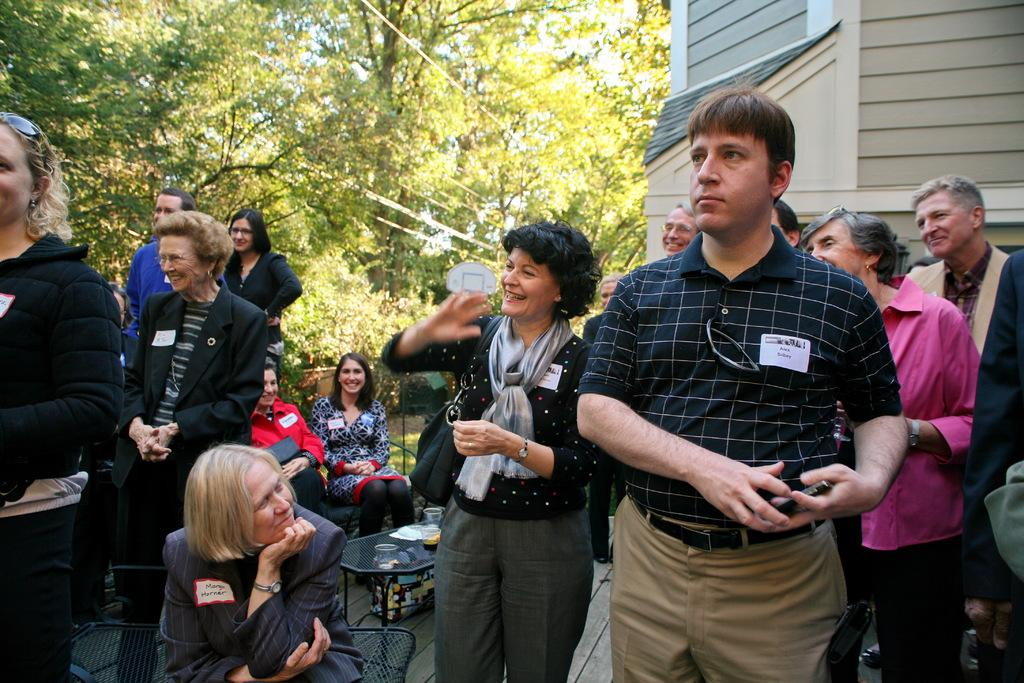How many people are in the image? There is a group of people in the image, but the exact number cannot be determined from the provided facts. What type of furniture is present in the image? There are chairs and a table in the image. What items are on the table? There are plates and glasses on the table in the image. What can be seen in the background of the image? There are trees and a building in the background of the image. Who is the writer of the humorous story being told by the group in the image? There is no mention of a humorous story or a writer in the image or the provided facts. 